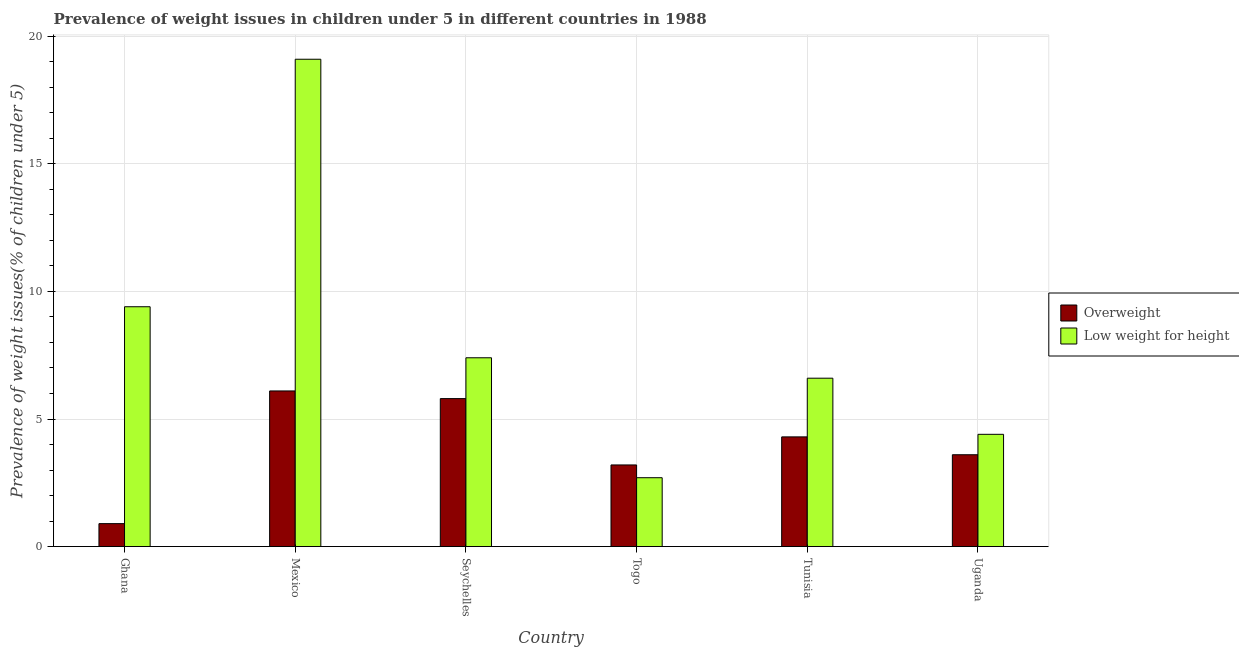How many bars are there on the 4th tick from the left?
Give a very brief answer. 2. How many bars are there on the 5th tick from the right?
Keep it short and to the point. 2. What is the label of the 4th group of bars from the left?
Make the answer very short. Togo. In how many cases, is the number of bars for a given country not equal to the number of legend labels?
Your answer should be compact. 0. What is the percentage of underweight children in Togo?
Give a very brief answer. 2.7. Across all countries, what is the maximum percentage of underweight children?
Your answer should be very brief. 19.1. Across all countries, what is the minimum percentage of underweight children?
Keep it short and to the point. 2.7. In which country was the percentage of overweight children minimum?
Provide a short and direct response. Ghana. What is the total percentage of underweight children in the graph?
Ensure brevity in your answer.  49.6. What is the difference between the percentage of underweight children in Togo and that in Uganda?
Keep it short and to the point. -1.7. What is the difference between the percentage of overweight children in Seychelles and the percentage of underweight children in Togo?
Offer a terse response. 3.1. What is the average percentage of overweight children per country?
Your answer should be compact. 3.98. What is the ratio of the percentage of overweight children in Mexico to that in Seychelles?
Provide a succinct answer. 1.05. Is the percentage of overweight children in Ghana less than that in Tunisia?
Offer a very short reply. Yes. What is the difference between the highest and the second highest percentage of overweight children?
Keep it short and to the point. 0.3. What is the difference between the highest and the lowest percentage of underweight children?
Provide a short and direct response. 16.4. In how many countries, is the percentage of overweight children greater than the average percentage of overweight children taken over all countries?
Your response must be concise. 3. Is the sum of the percentage of underweight children in Mexico and Uganda greater than the maximum percentage of overweight children across all countries?
Provide a short and direct response. Yes. What does the 2nd bar from the left in Togo represents?
Make the answer very short. Low weight for height. What does the 1st bar from the right in Seychelles represents?
Your response must be concise. Low weight for height. How many countries are there in the graph?
Provide a short and direct response. 6. Does the graph contain any zero values?
Make the answer very short. No. How many legend labels are there?
Keep it short and to the point. 2. How are the legend labels stacked?
Offer a terse response. Vertical. What is the title of the graph?
Your answer should be very brief. Prevalence of weight issues in children under 5 in different countries in 1988. What is the label or title of the X-axis?
Keep it short and to the point. Country. What is the label or title of the Y-axis?
Provide a short and direct response. Prevalence of weight issues(% of children under 5). What is the Prevalence of weight issues(% of children under 5) of Overweight in Ghana?
Your answer should be compact. 0.9. What is the Prevalence of weight issues(% of children under 5) in Low weight for height in Ghana?
Provide a succinct answer. 9.4. What is the Prevalence of weight issues(% of children under 5) of Overweight in Mexico?
Provide a succinct answer. 6.1. What is the Prevalence of weight issues(% of children under 5) in Low weight for height in Mexico?
Provide a short and direct response. 19.1. What is the Prevalence of weight issues(% of children under 5) in Overweight in Seychelles?
Ensure brevity in your answer.  5.8. What is the Prevalence of weight issues(% of children under 5) of Low weight for height in Seychelles?
Your answer should be compact. 7.4. What is the Prevalence of weight issues(% of children under 5) of Overweight in Togo?
Offer a terse response. 3.2. What is the Prevalence of weight issues(% of children under 5) in Low weight for height in Togo?
Offer a terse response. 2.7. What is the Prevalence of weight issues(% of children under 5) of Overweight in Tunisia?
Your answer should be compact. 4.3. What is the Prevalence of weight issues(% of children under 5) of Low weight for height in Tunisia?
Your answer should be very brief. 6.6. What is the Prevalence of weight issues(% of children under 5) of Overweight in Uganda?
Provide a succinct answer. 3.6. What is the Prevalence of weight issues(% of children under 5) in Low weight for height in Uganda?
Keep it short and to the point. 4.4. Across all countries, what is the maximum Prevalence of weight issues(% of children under 5) of Overweight?
Give a very brief answer. 6.1. Across all countries, what is the maximum Prevalence of weight issues(% of children under 5) of Low weight for height?
Give a very brief answer. 19.1. Across all countries, what is the minimum Prevalence of weight issues(% of children under 5) of Overweight?
Offer a very short reply. 0.9. Across all countries, what is the minimum Prevalence of weight issues(% of children under 5) in Low weight for height?
Provide a succinct answer. 2.7. What is the total Prevalence of weight issues(% of children under 5) in Overweight in the graph?
Give a very brief answer. 23.9. What is the total Prevalence of weight issues(% of children under 5) in Low weight for height in the graph?
Make the answer very short. 49.6. What is the difference between the Prevalence of weight issues(% of children under 5) in Overweight in Ghana and that in Seychelles?
Give a very brief answer. -4.9. What is the difference between the Prevalence of weight issues(% of children under 5) in Low weight for height in Ghana and that in Seychelles?
Your answer should be compact. 2. What is the difference between the Prevalence of weight issues(% of children under 5) of Low weight for height in Ghana and that in Tunisia?
Your response must be concise. 2.8. What is the difference between the Prevalence of weight issues(% of children under 5) in Overweight in Ghana and that in Uganda?
Your answer should be compact. -2.7. What is the difference between the Prevalence of weight issues(% of children under 5) of Overweight in Mexico and that in Togo?
Make the answer very short. 2.9. What is the difference between the Prevalence of weight issues(% of children under 5) of Overweight in Mexico and that in Tunisia?
Provide a succinct answer. 1.8. What is the difference between the Prevalence of weight issues(% of children under 5) of Low weight for height in Mexico and that in Tunisia?
Keep it short and to the point. 12.5. What is the difference between the Prevalence of weight issues(% of children under 5) in Overweight in Mexico and that in Uganda?
Make the answer very short. 2.5. What is the difference between the Prevalence of weight issues(% of children under 5) of Overweight in Seychelles and that in Togo?
Ensure brevity in your answer.  2.6. What is the difference between the Prevalence of weight issues(% of children under 5) of Low weight for height in Seychelles and that in Togo?
Keep it short and to the point. 4.7. What is the difference between the Prevalence of weight issues(% of children under 5) of Low weight for height in Seychelles and that in Tunisia?
Make the answer very short. 0.8. What is the difference between the Prevalence of weight issues(% of children under 5) in Low weight for height in Seychelles and that in Uganda?
Provide a succinct answer. 3. What is the difference between the Prevalence of weight issues(% of children under 5) in Low weight for height in Togo and that in Tunisia?
Ensure brevity in your answer.  -3.9. What is the difference between the Prevalence of weight issues(% of children under 5) in Overweight in Togo and that in Uganda?
Offer a terse response. -0.4. What is the difference between the Prevalence of weight issues(% of children under 5) in Overweight in Tunisia and that in Uganda?
Provide a short and direct response. 0.7. What is the difference between the Prevalence of weight issues(% of children under 5) of Low weight for height in Tunisia and that in Uganda?
Ensure brevity in your answer.  2.2. What is the difference between the Prevalence of weight issues(% of children under 5) in Overweight in Ghana and the Prevalence of weight issues(% of children under 5) in Low weight for height in Mexico?
Give a very brief answer. -18.2. What is the difference between the Prevalence of weight issues(% of children under 5) of Overweight in Ghana and the Prevalence of weight issues(% of children under 5) of Low weight for height in Seychelles?
Provide a short and direct response. -6.5. What is the difference between the Prevalence of weight issues(% of children under 5) of Overweight in Ghana and the Prevalence of weight issues(% of children under 5) of Low weight for height in Togo?
Ensure brevity in your answer.  -1.8. What is the difference between the Prevalence of weight issues(% of children under 5) of Overweight in Mexico and the Prevalence of weight issues(% of children under 5) of Low weight for height in Togo?
Provide a short and direct response. 3.4. What is the difference between the Prevalence of weight issues(% of children under 5) of Overweight in Mexico and the Prevalence of weight issues(% of children under 5) of Low weight for height in Tunisia?
Your response must be concise. -0.5. What is the difference between the Prevalence of weight issues(% of children under 5) in Overweight in Mexico and the Prevalence of weight issues(% of children under 5) in Low weight for height in Uganda?
Your answer should be very brief. 1.7. What is the difference between the Prevalence of weight issues(% of children under 5) of Overweight in Seychelles and the Prevalence of weight issues(% of children under 5) of Low weight for height in Togo?
Give a very brief answer. 3.1. What is the difference between the Prevalence of weight issues(% of children under 5) of Overweight in Seychelles and the Prevalence of weight issues(% of children under 5) of Low weight for height in Tunisia?
Your answer should be compact. -0.8. What is the difference between the Prevalence of weight issues(% of children under 5) of Overweight in Togo and the Prevalence of weight issues(% of children under 5) of Low weight for height in Uganda?
Keep it short and to the point. -1.2. What is the average Prevalence of weight issues(% of children under 5) in Overweight per country?
Your response must be concise. 3.98. What is the average Prevalence of weight issues(% of children under 5) in Low weight for height per country?
Give a very brief answer. 8.27. What is the difference between the Prevalence of weight issues(% of children under 5) of Overweight and Prevalence of weight issues(% of children under 5) of Low weight for height in Mexico?
Offer a terse response. -13. What is the difference between the Prevalence of weight issues(% of children under 5) of Overweight and Prevalence of weight issues(% of children under 5) of Low weight for height in Seychelles?
Your answer should be compact. -1.6. What is the difference between the Prevalence of weight issues(% of children under 5) in Overweight and Prevalence of weight issues(% of children under 5) in Low weight for height in Tunisia?
Make the answer very short. -2.3. What is the ratio of the Prevalence of weight issues(% of children under 5) of Overweight in Ghana to that in Mexico?
Your answer should be very brief. 0.15. What is the ratio of the Prevalence of weight issues(% of children under 5) of Low weight for height in Ghana to that in Mexico?
Keep it short and to the point. 0.49. What is the ratio of the Prevalence of weight issues(% of children under 5) of Overweight in Ghana to that in Seychelles?
Provide a short and direct response. 0.16. What is the ratio of the Prevalence of weight issues(% of children under 5) of Low weight for height in Ghana to that in Seychelles?
Your answer should be compact. 1.27. What is the ratio of the Prevalence of weight issues(% of children under 5) in Overweight in Ghana to that in Togo?
Your answer should be very brief. 0.28. What is the ratio of the Prevalence of weight issues(% of children under 5) in Low weight for height in Ghana to that in Togo?
Give a very brief answer. 3.48. What is the ratio of the Prevalence of weight issues(% of children under 5) in Overweight in Ghana to that in Tunisia?
Make the answer very short. 0.21. What is the ratio of the Prevalence of weight issues(% of children under 5) of Low weight for height in Ghana to that in Tunisia?
Your answer should be compact. 1.42. What is the ratio of the Prevalence of weight issues(% of children under 5) in Low weight for height in Ghana to that in Uganda?
Your response must be concise. 2.14. What is the ratio of the Prevalence of weight issues(% of children under 5) of Overweight in Mexico to that in Seychelles?
Your answer should be compact. 1.05. What is the ratio of the Prevalence of weight issues(% of children under 5) of Low weight for height in Mexico to that in Seychelles?
Ensure brevity in your answer.  2.58. What is the ratio of the Prevalence of weight issues(% of children under 5) in Overweight in Mexico to that in Togo?
Offer a very short reply. 1.91. What is the ratio of the Prevalence of weight issues(% of children under 5) in Low weight for height in Mexico to that in Togo?
Provide a succinct answer. 7.07. What is the ratio of the Prevalence of weight issues(% of children under 5) of Overweight in Mexico to that in Tunisia?
Make the answer very short. 1.42. What is the ratio of the Prevalence of weight issues(% of children under 5) in Low weight for height in Mexico to that in Tunisia?
Offer a terse response. 2.89. What is the ratio of the Prevalence of weight issues(% of children under 5) of Overweight in Mexico to that in Uganda?
Your response must be concise. 1.69. What is the ratio of the Prevalence of weight issues(% of children under 5) of Low weight for height in Mexico to that in Uganda?
Your response must be concise. 4.34. What is the ratio of the Prevalence of weight issues(% of children under 5) of Overweight in Seychelles to that in Togo?
Your answer should be very brief. 1.81. What is the ratio of the Prevalence of weight issues(% of children under 5) in Low weight for height in Seychelles to that in Togo?
Your answer should be very brief. 2.74. What is the ratio of the Prevalence of weight issues(% of children under 5) in Overweight in Seychelles to that in Tunisia?
Your answer should be very brief. 1.35. What is the ratio of the Prevalence of weight issues(% of children under 5) in Low weight for height in Seychelles to that in Tunisia?
Keep it short and to the point. 1.12. What is the ratio of the Prevalence of weight issues(% of children under 5) in Overweight in Seychelles to that in Uganda?
Make the answer very short. 1.61. What is the ratio of the Prevalence of weight issues(% of children under 5) in Low weight for height in Seychelles to that in Uganda?
Offer a terse response. 1.68. What is the ratio of the Prevalence of weight issues(% of children under 5) in Overweight in Togo to that in Tunisia?
Keep it short and to the point. 0.74. What is the ratio of the Prevalence of weight issues(% of children under 5) of Low weight for height in Togo to that in Tunisia?
Provide a succinct answer. 0.41. What is the ratio of the Prevalence of weight issues(% of children under 5) in Low weight for height in Togo to that in Uganda?
Provide a short and direct response. 0.61. What is the ratio of the Prevalence of weight issues(% of children under 5) in Overweight in Tunisia to that in Uganda?
Ensure brevity in your answer.  1.19. What is the difference between the highest and the second highest Prevalence of weight issues(% of children under 5) in Overweight?
Provide a short and direct response. 0.3. What is the difference between the highest and the second highest Prevalence of weight issues(% of children under 5) in Low weight for height?
Keep it short and to the point. 9.7. What is the difference between the highest and the lowest Prevalence of weight issues(% of children under 5) of Overweight?
Your response must be concise. 5.2. 